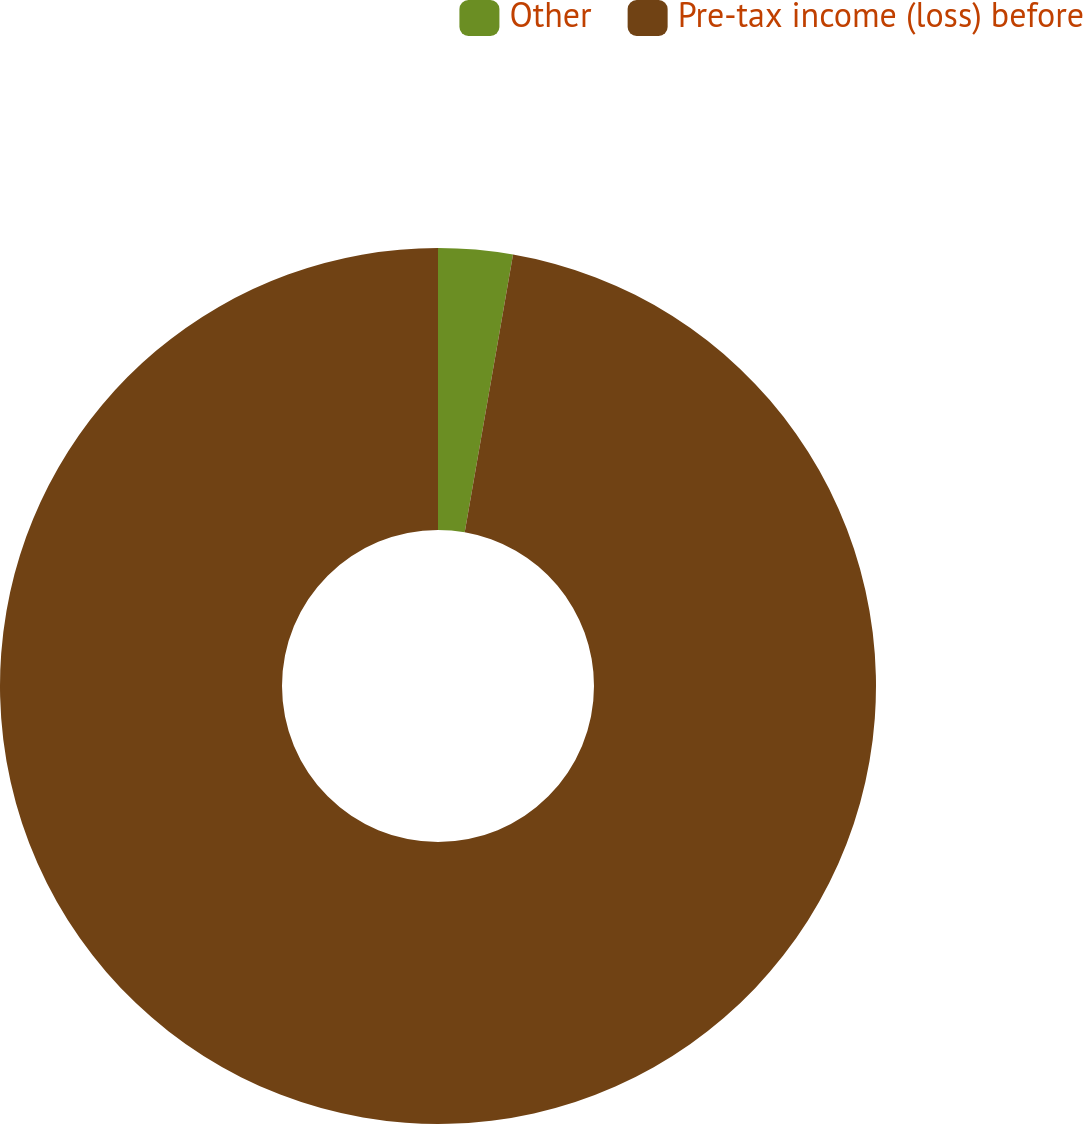Convert chart to OTSL. <chart><loc_0><loc_0><loc_500><loc_500><pie_chart><fcel>Other<fcel>Pre-tax income (loss) before<nl><fcel>2.74%<fcel>97.26%<nl></chart> 